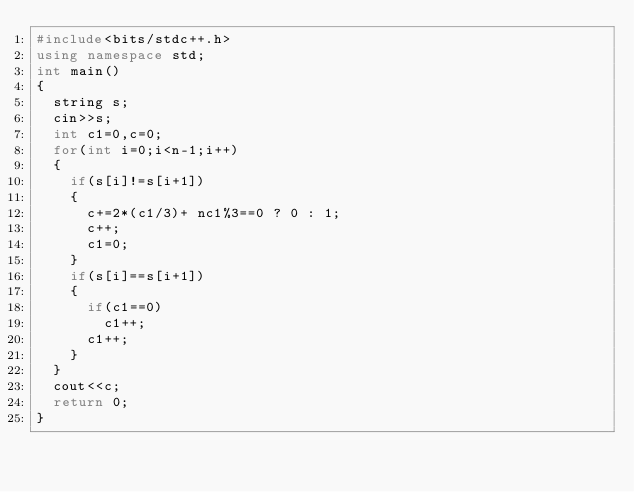<code> <loc_0><loc_0><loc_500><loc_500><_C++_>#include<bits/stdc++.h>
using namespace std;
int main()
{
  string s;
  cin>>s;
  int c1=0,c=0;
  for(int i=0;i<n-1;i++)
  {
    if(s[i]!=s[i+1])
    {
      c+=2*(c1/3)+ nc1%3==0 ? 0 : 1;
      c++;
      c1=0;
    }
    if(s[i]==s[i+1])
    {
      if(c1==0)
        c1++;
      c1++;
    }
  }
  cout<<c;
  return 0;
}</code> 